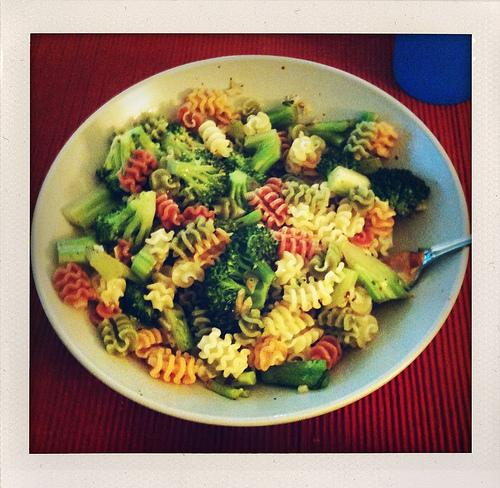What is in the bowl? Please explain your reasoning. pasta. The contents of the bowl is clearly visible and is a color, shape and size consistent with answer a. 